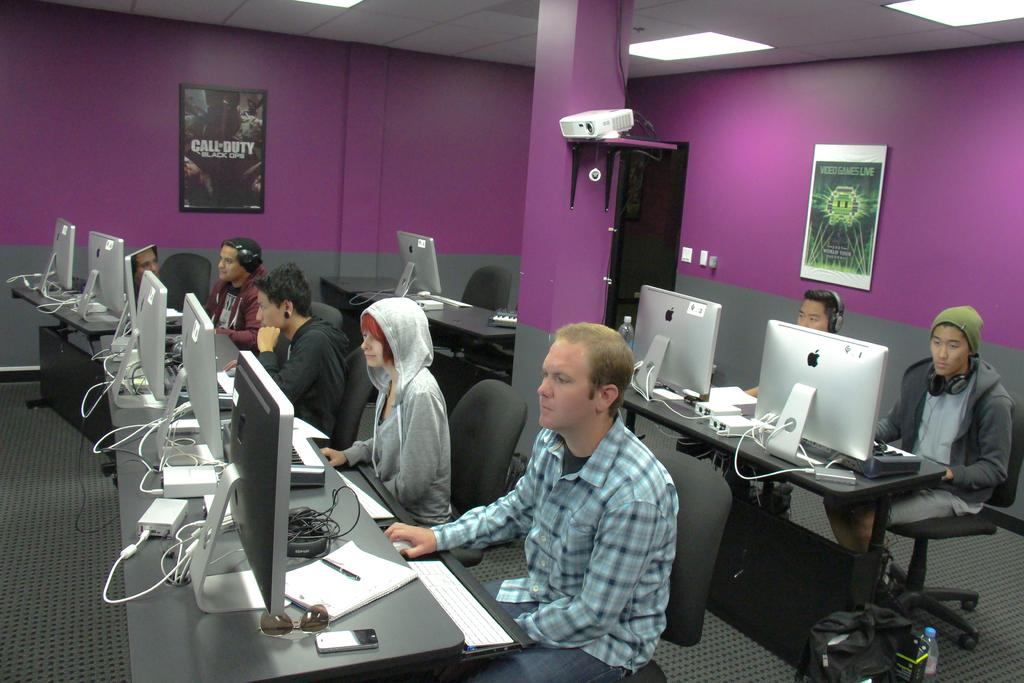<image>
Write a terse but informative summary of the picture. rows of people at computers and posters on wall for video games live and call of duty black ops 